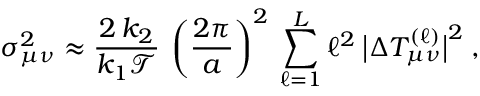Convert formula to latex. <formula><loc_0><loc_0><loc_500><loc_500>\sigma _ { \mu \nu } ^ { 2 } \approx \frac { 2 \, k _ { 2 } } { k _ { 1 } \mathcal { T } } \, \left ( \frac { 2 \pi } { a } \right ) ^ { 2 } \, \sum _ { \ell = 1 } ^ { L } \ell ^ { 2 } \, \left | \Delta T _ { \mu \nu } ^ { ( \ell ) } \right | ^ { 2 } \, ,</formula> 